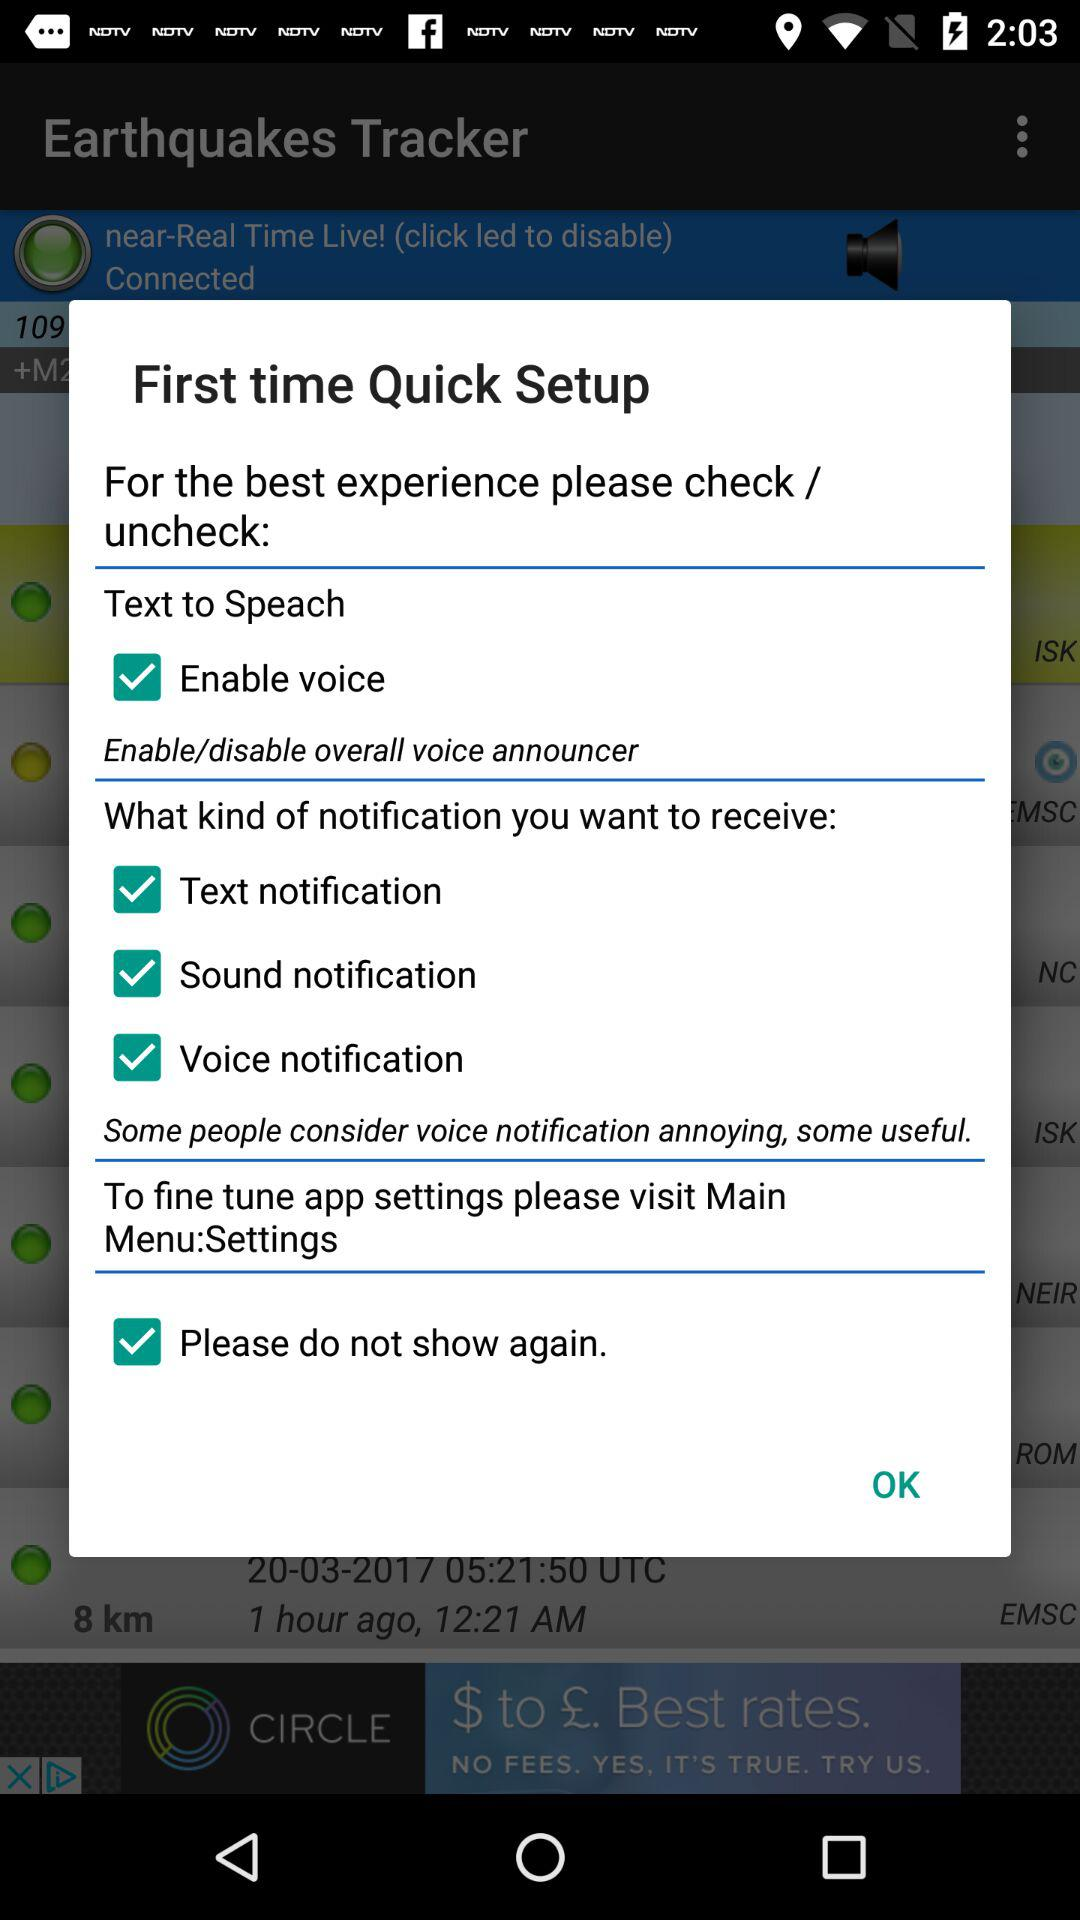How many notification types are there?
Answer the question using a single word or phrase. 3 